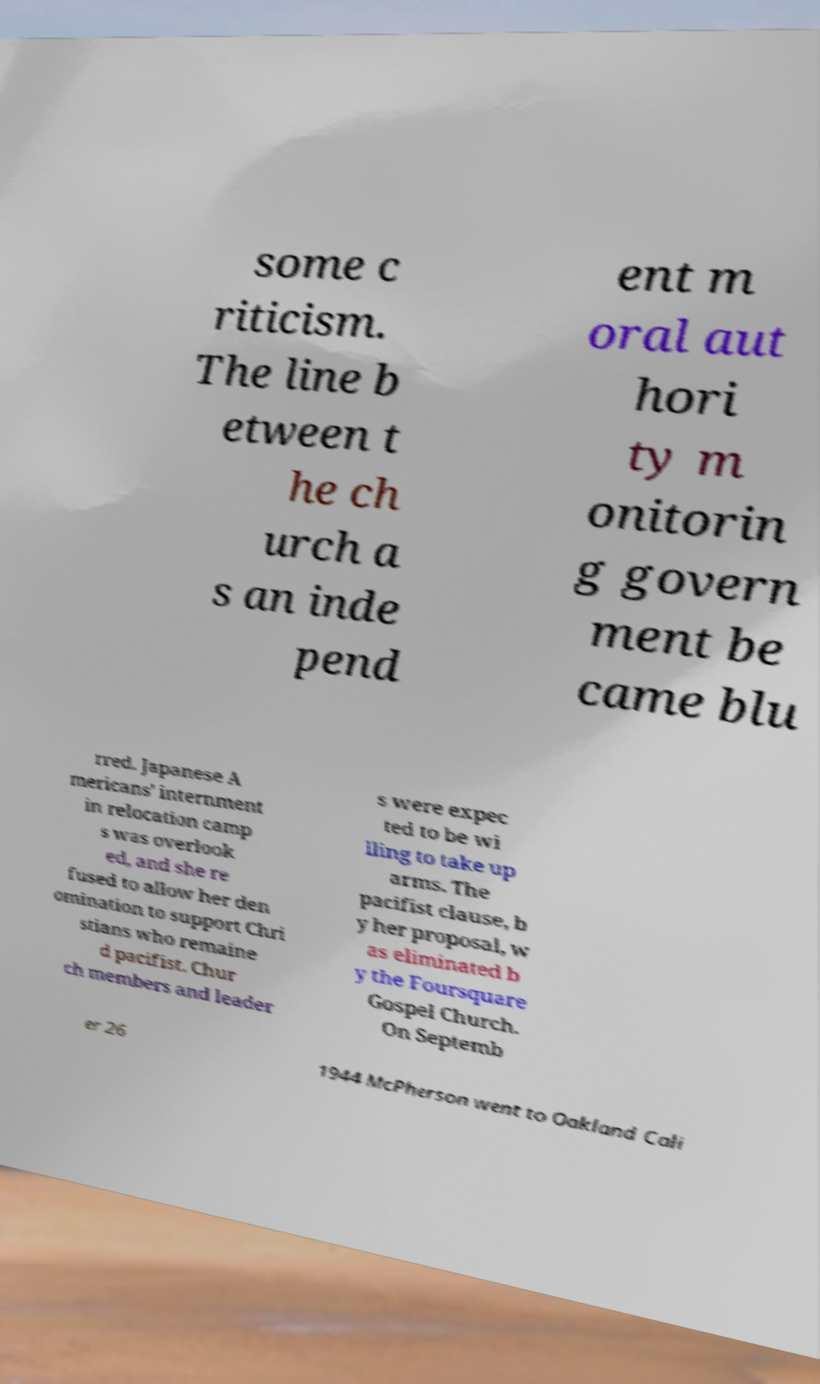Can you read and provide the text displayed in the image?This photo seems to have some interesting text. Can you extract and type it out for me? some c riticism. The line b etween t he ch urch a s an inde pend ent m oral aut hori ty m onitorin g govern ment be came blu rred. Japanese A mericans' internment in relocation camp s was overlook ed, and she re fused to allow her den omination to support Chri stians who remaine d pacifist. Chur ch members and leader s were expec ted to be wi lling to take up arms. The pacifist clause, b y her proposal, w as eliminated b y the Foursquare Gospel Church. On Septemb er 26 1944 McPherson went to Oakland Cali 